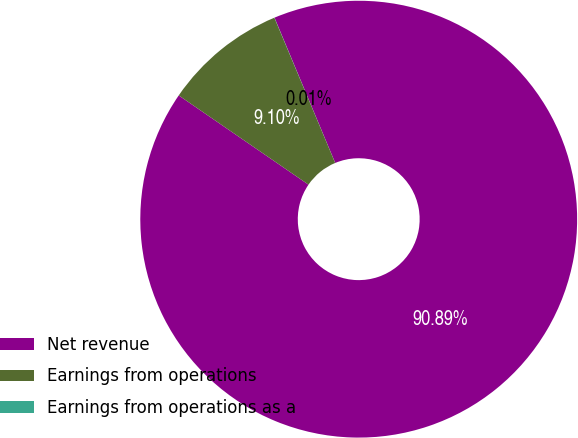Convert chart to OTSL. <chart><loc_0><loc_0><loc_500><loc_500><pie_chart><fcel>Net revenue<fcel>Earnings from operations<fcel>Earnings from operations as a<nl><fcel>90.89%<fcel>9.1%<fcel>0.01%<nl></chart> 